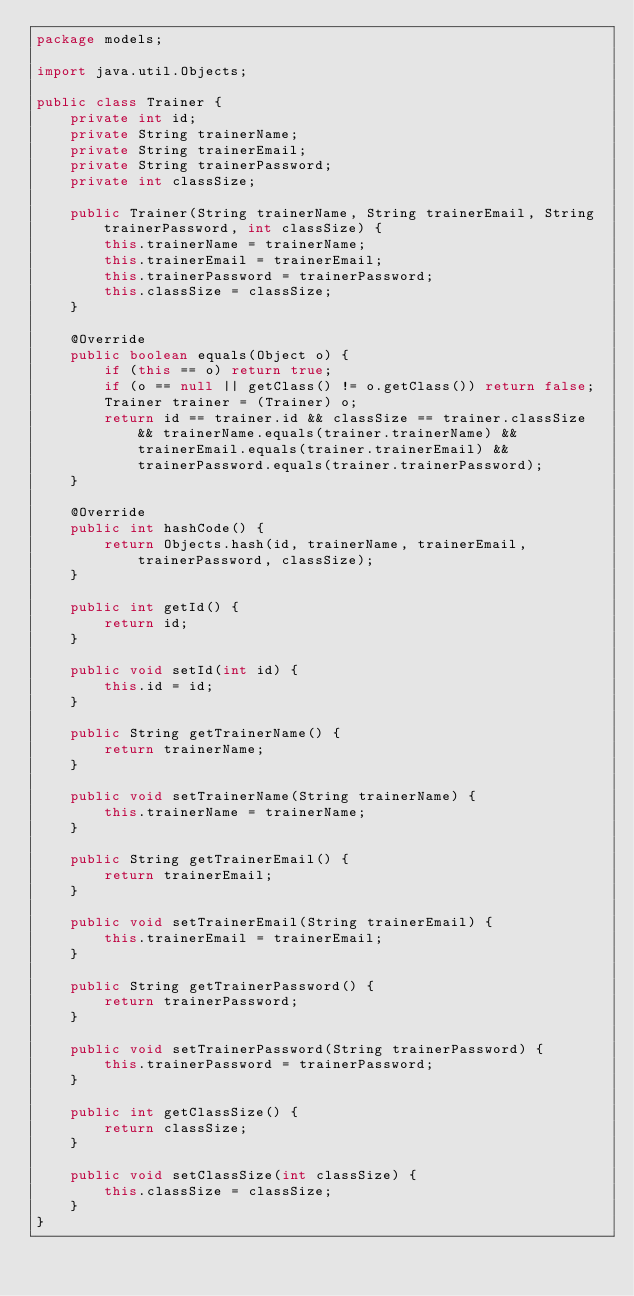<code> <loc_0><loc_0><loc_500><loc_500><_Java_>package models;

import java.util.Objects;

public class Trainer {
    private int id;
    private String trainerName;
    private String trainerEmail;
    private String trainerPassword;
    private int classSize;

    public Trainer(String trainerName, String trainerEmail, String trainerPassword, int classSize) {
        this.trainerName = trainerName;
        this.trainerEmail = trainerEmail;
        this.trainerPassword = trainerPassword;
        this.classSize = classSize;
    }

    @Override
    public boolean equals(Object o) {
        if (this == o) return true;
        if (o == null || getClass() != o.getClass()) return false;
        Trainer trainer = (Trainer) o;
        return id == trainer.id && classSize == trainer.classSize && trainerName.equals(trainer.trainerName) && trainerEmail.equals(trainer.trainerEmail) && trainerPassword.equals(trainer.trainerPassword);
    }

    @Override
    public int hashCode() {
        return Objects.hash(id, trainerName, trainerEmail, trainerPassword, classSize);
    }

    public int getId() {
        return id;
    }

    public void setId(int id) {
        this.id = id;
    }

    public String getTrainerName() {
        return trainerName;
    }

    public void setTrainerName(String trainerName) {
        this.trainerName = trainerName;
    }

    public String getTrainerEmail() {
        return trainerEmail;
    }

    public void setTrainerEmail(String trainerEmail) {
        this.trainerEmail = trainerEmail;
    }

    public String getTrainerPassword() {
        return trainerPassword;
    }

    public void setTrainerPassword(String trainerPassword) {
        this.trainerPassword = trainerPassword;
    }

    public int getClassSize() {
        return classSize;
    }

    public void setClassSize(int classSize) {
        this.classSize = classSize;
    }
}
</code> 